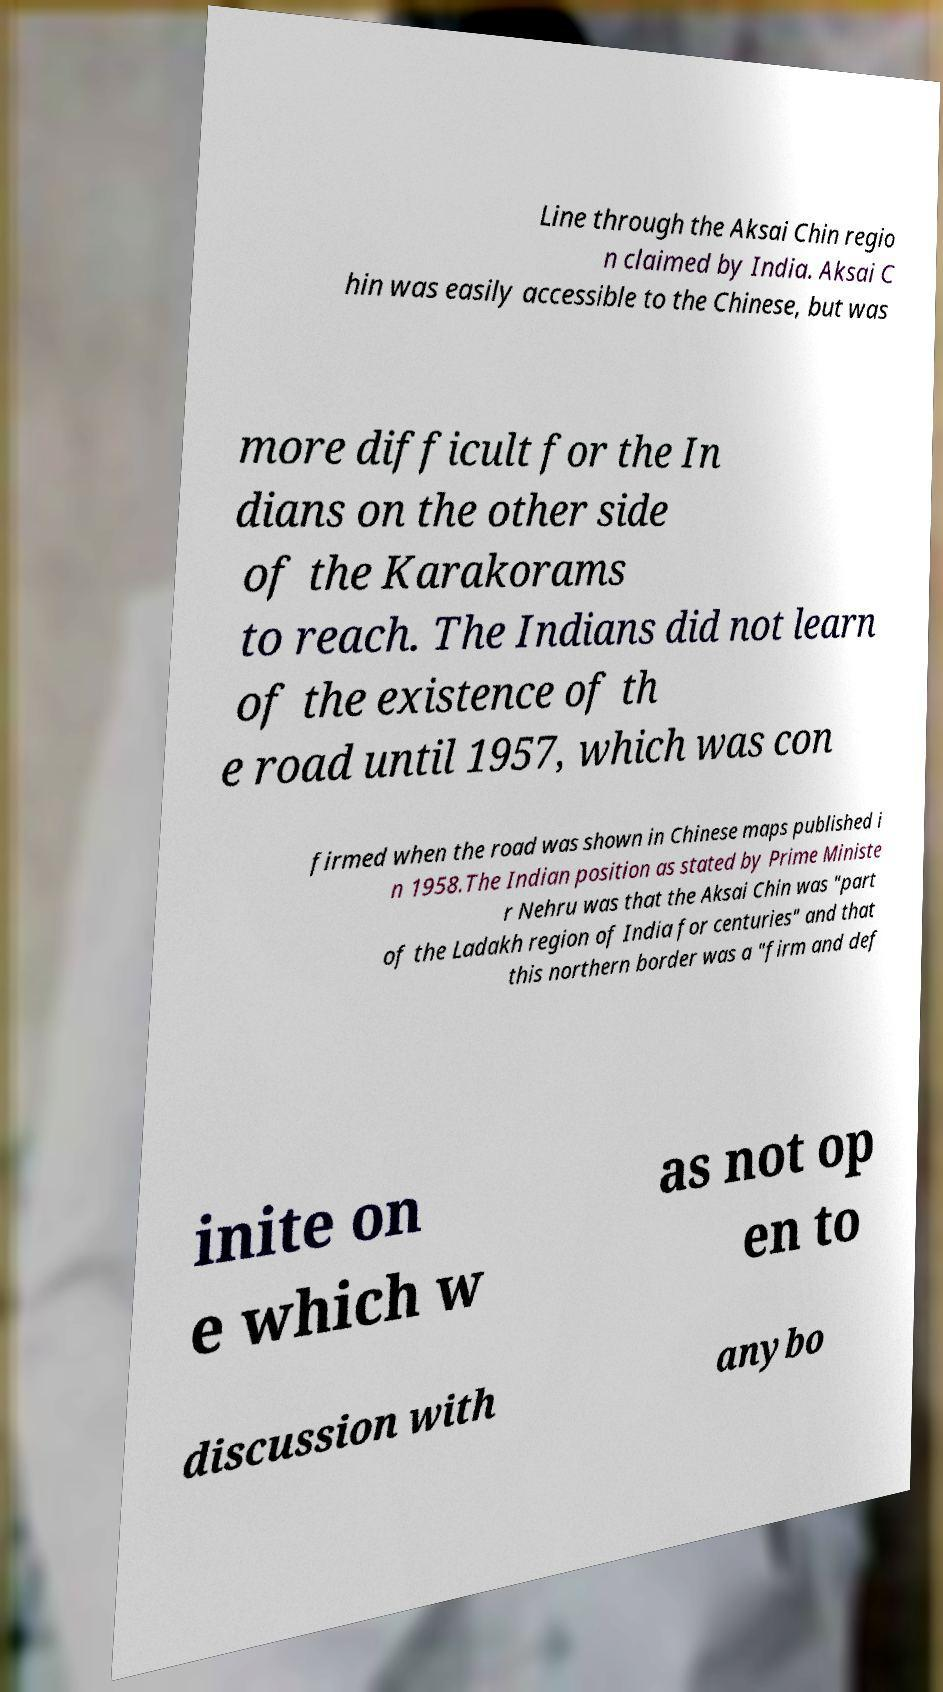What messages or text are displayed in this image? I need them in a readable, typed format. Line through the Aksai Chin regio n claimed by India. Aksai C hin was easily accessible to the Chinese, but was more difficult for the In dians on the other side of the Karakorams to reach. The Indians did not learn of the existence of th e road until 1957, which was con firmed when the road was shown in Chinese maps published i n 1958.The Indian position as stated by Prime Ministe r Nehru was that the Aksai Chin was "part of the Ladakh region of India for centuries" and that this northern border was a "firm and def inite on e which w as not op en to discussion with anybo 